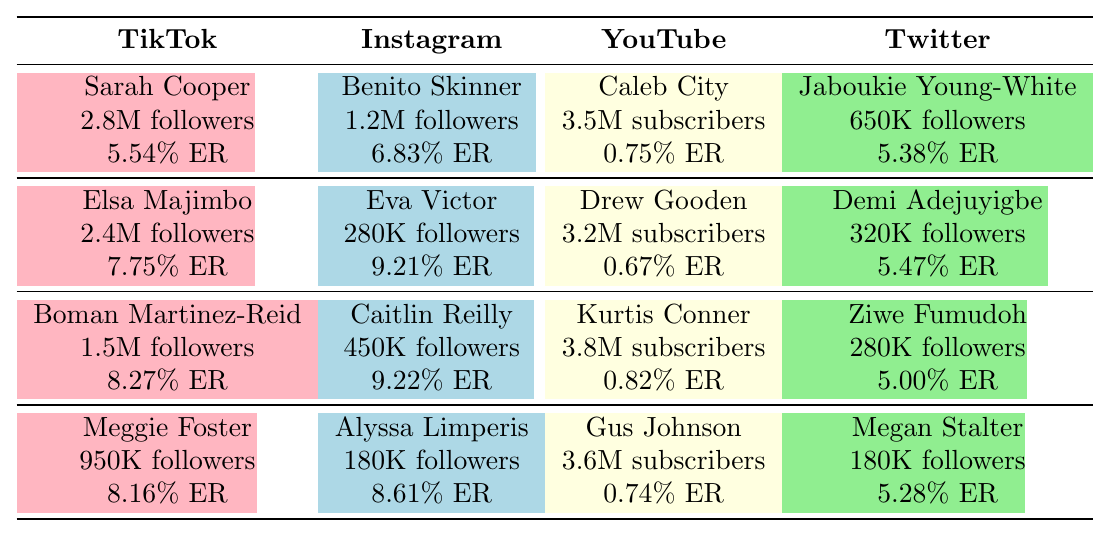What is the engagement rate of Sarah Cooper on TikTok? According to the table, Sarah Cooper has an engagement rate of 5.54%.
Answer: 5.54% Which comedian has the highest engagement rate on Instagram? By comparing the engagement rates listed for each Instagram comedian, Caitlin Reilly has the highest engagement rate at 9.22%.
Answer: Caitlin Reilly What is the average engagement rate of comedians on Twitter? The engagement rates for Twitter comedians are: 5.38%, 5.47%, 5.00%, and 5.28%. Adding them up gives 21.13%, and dividing by four gives an average of 5.2825%, which rounds to 5.28%.
Answer: 5.28% True or False: Elsa Majimbo has more followers than Boman Martinez-Reid on TikTok. Looking at the follower counts, Elsa Majimbo has 2.4 million while Boman Martinez-Reid has 1.5 million, so the statement is true.
Answer: True Who has the most followers among the TikTok comedians? By inspecting the follower counts, Sarah Cooper has 2,800,000 which is higher than the others listed, making her the one with the most followers.
Answer: Sarah Cooper If you combined the followers of all comedians on Instagram, how many would you have? The follower counts on Instagram are: 1.2M, 0.28M, 0.45M, and 0.18M. Converting them all to millions and summing gives 2.13 million followers.
Answer: 2.13 million Which platform has the lowest average engagement rate overall? The engagement rates for YouTube are significantly lower than the others, with rates of 0.75%, 0.67%, 0.82%, and 0.74%. Their average is 0.745%, which is lower than the engagement rates from platforms like TikTok, Instagram, and Twitter.
Answer: YouTube What is the difference in engagement rates between the highest and lowest engagement rates among the TikTok comedians? The highest engagement rate on TikTok is 8.27% (Boman Martinez-Reid) and the lowest is 5.54% (Sarah Cooper). The difference is calculated as 8.27% - 5.54% = 2.73%.
Answer: 2.73% Which comedian has the least number of followers on Twitter? Among the Twitter comedians, Megan Stalter has 180,000 followers, which is fewer than the other three comedians listed.
Answer: Megan Stalter Is there a comedian on Instagram with fewer than 300,000 followers? Eva Victor has 280,000 followers, which is fewer than 300,000. Therefore, the statement is true.
Answer: True 